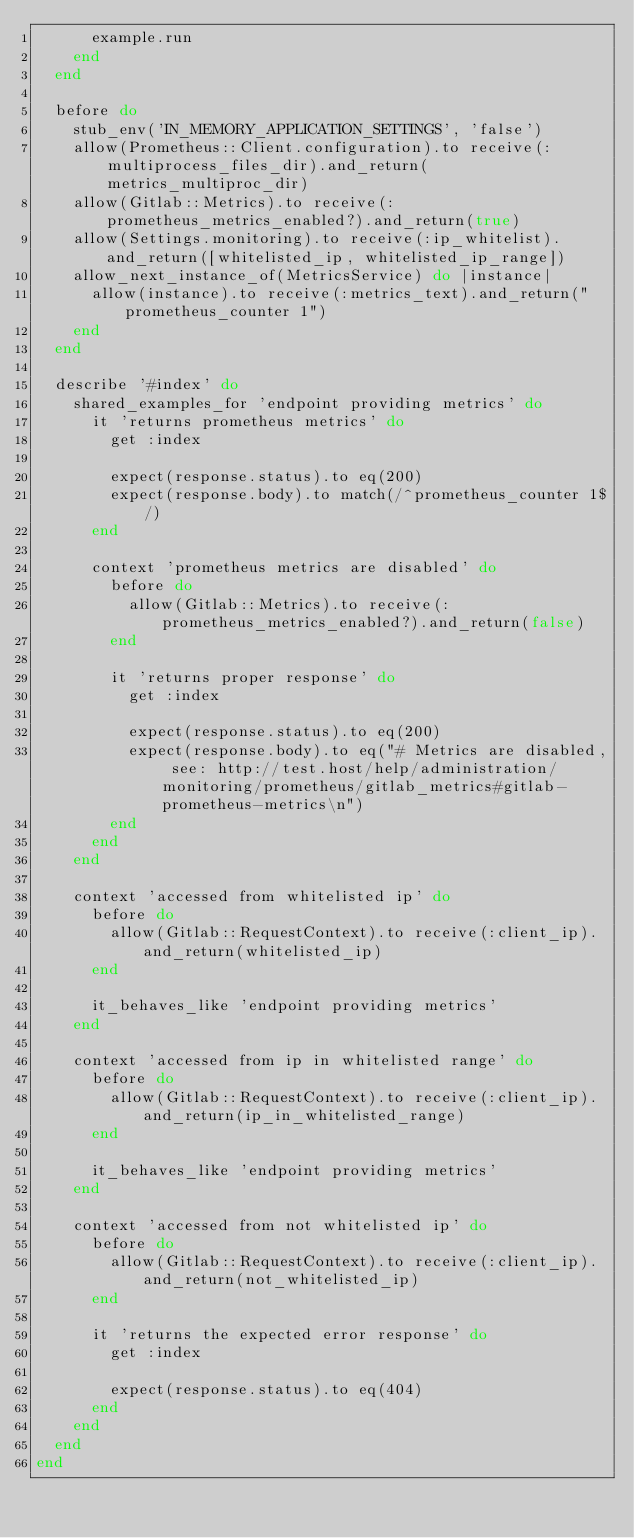<code> <loc_0><loc_0><loc_500><loc_500><_Ruby_>      example.run
    end
  end

  before do
    stub_env('IN_MEMORY_APPLICATION_SETTINGS', 'false')
    allow(Prometheus::Client.configuration).to receive(:multiprocess_files_dir).and_return(metrics_multiproc_dir)
    allow(Gitlab::Metrics).to receive(:prometheus_metrics_enabled?).and_return(true)
    allow(Settings.monitoring).to receive(:ip_whitelist).and_return([whitelisted_ip, whitelisted_ip_range])
    allow_next_instance_of(MetricsService) do |instance|
      allow(instance).to receive(:metrics_text).and_return("prometheus_counter 1")
    end
  end

  describe '#index' do
    shared_examples_for 'endpoint providing metrics' do
      it 'returns prometheus metrics' do
        get :index

        expect(response.status).to eq(200)
        expect(response.body).to match(/^prometheus_counter 1$/)
      end

      context 'prometheus metrics are disabled' do
        before do
          allow(Gitlab::Metrics).to receive(:prometheus_metrics_enabled?).and_return(false)
        end

        it 'returns proper response' do
          get :index

          expect(response.status).to eq(200)
          expect(response.body).to eq("# Metrics are disabled, see: http://test.host/help/administration/monitoring/prometheus/gitlab_metrics#gitlab-prometheus-metrics\n")
        end
      end
    end

    context 'accessed from whitelisted ip' do
      before do
        allow(Gitlab::RequestContext).to receive(:client_ip).and_return(whitelisted_ip)
      end

      it_behaves_like 'endpoint providing metrics'
    end

    context 'accessed from ip in whitelisted range' do
      before do
        allow(Gitlab::RequestContext).to receive(:client_ip).and_return(ip_in_whitelisted_range)
      end

      it_behaves_like 'endpoint providing metrics'
    end

    context 'accessed from not whitelisted ip' do
      before do
        allow(Gitlab::RequestContext).to receive(:client_ip).and_return(not_whitelisted_ip)
      end

      it 'returns the expected error response' do
        get :index

        expect(response.status).to eq(404)
      end
    end
  end
end
</code> 